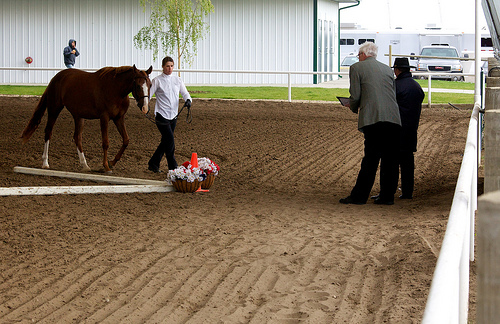<image>
Is there a horse next to the man? No. The horse is not positioned next to the man. They are located in different areas of the scene. Is there a man in front of the horse? Yes. The man is positioned in front of the horse, appearing closer to the camera viewpoint. 